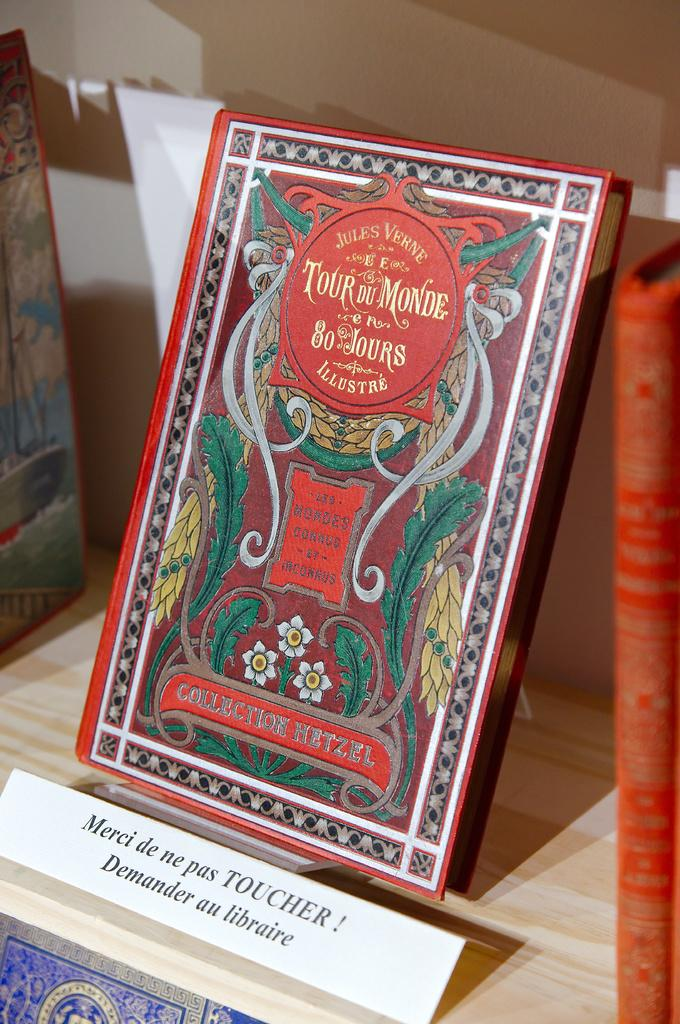<image>
Share a concise interpretation of the image provided. A book buy Jules Verne, titled Le Tour Du Monde en 80 Jours in French. 